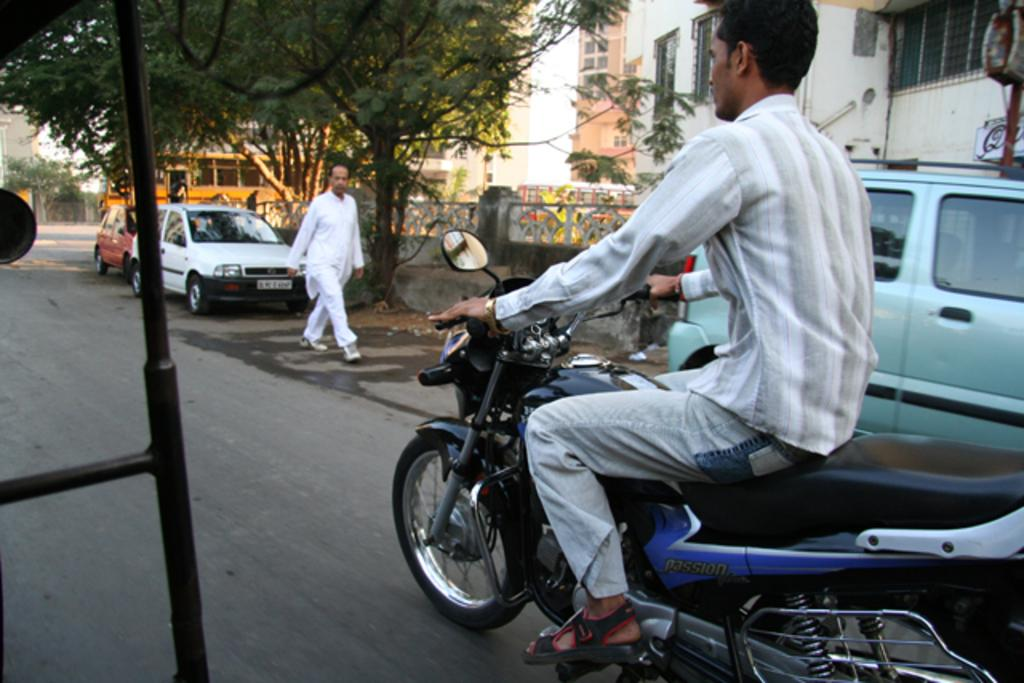What is the man in the image doing? The man is riding a bike on the road. What is the other person in the image doing? There is a person walking alongside the road. What types of vehicles are present on the road? Cars are present on the road. What can be seen in the background of the image? There is a bus, trees, buildings with windows, and a fence in the background. What color is the gold button on the man's shirt in the image? There is no mention of a gold button or any button on the man's shirt in the image. 